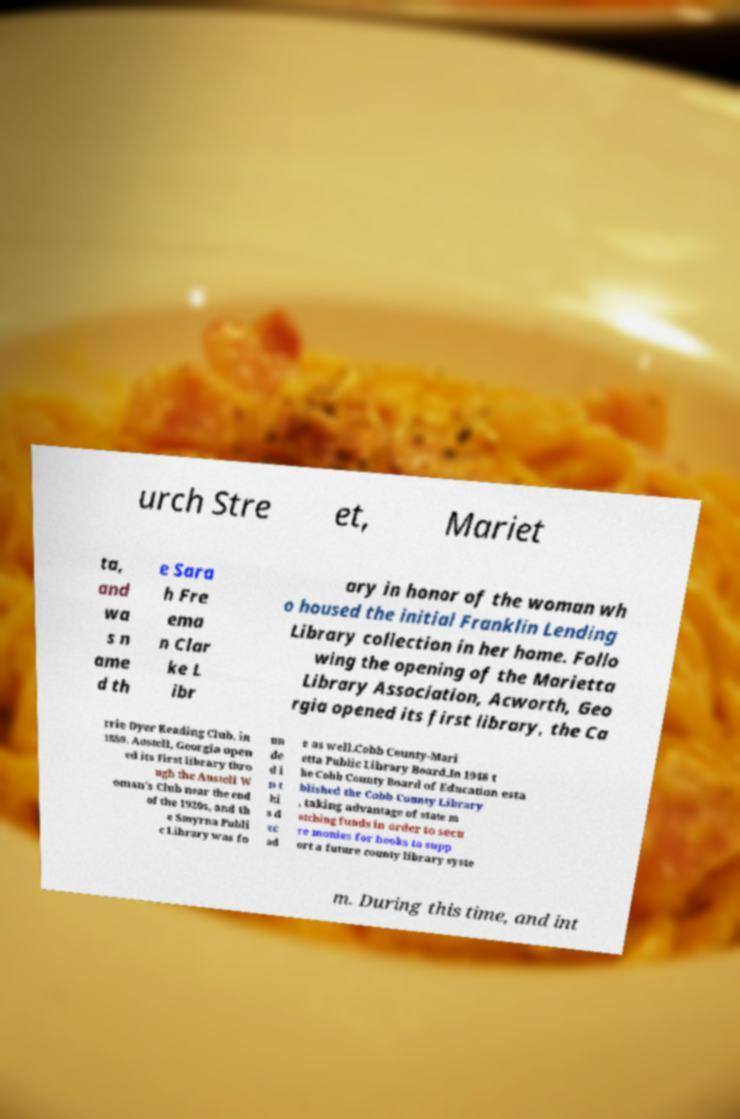What messages or text are displayed in this image? I need them in a readable, typed format. urch Stre et, Mariet ta, and wa s n ame d th e Sara h Fre ema n Clar ke L ibr ary in honor of the woman wh o housed the initial Franklin Lending Library collection in her home. Follo wing the opening of the Marietta Library Association, Acworth, Geo rgia opened its first library, the Ca rrie Dyer Reading Club, in 1889. Austell, Georgia open ed its first library thro ugh the Austell W oman's Club near the end of the 1920s, and th e Smyrna Publi c Library was fo un de d i n t hi s d ec ad e as well.Cobb County-Mari etta Public Library Board.In 1948 t he Cobb County Board of Education esta blished the Cobb County Library , taking advantage of state m atching funds in order to secu re monies for books to supp ort a future county library syste m. During this time, and int 